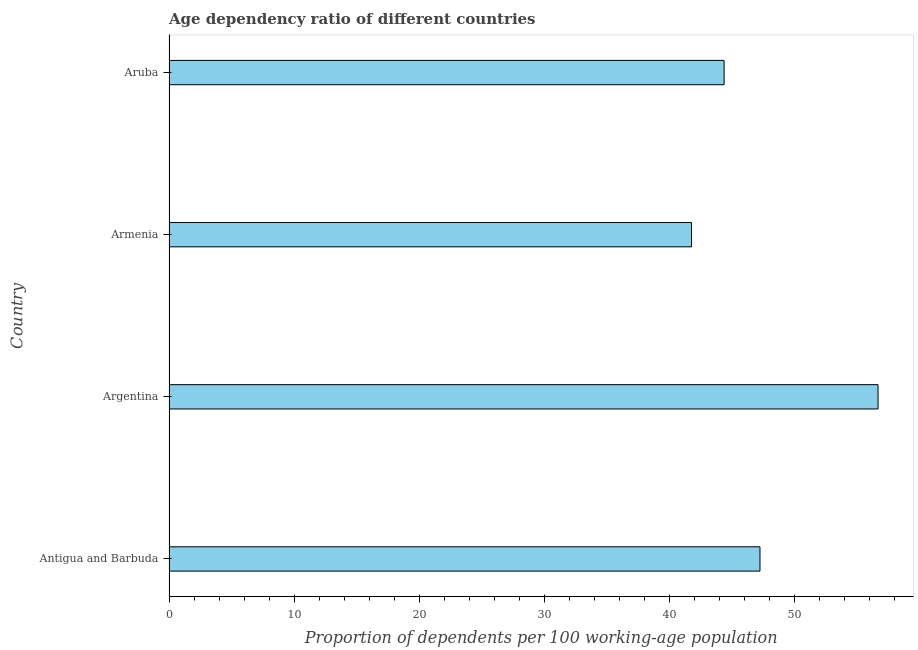Does the graph contain grids?
Your response must be concise. No. What is the title of the graph?
Give a very brief answer. Age dependency ratio of different countries. What is the label or title of the X-axis?
Provide a succinct answer. Proportion of dependents per 100 working-age population. What is the age dependency ratio in Argentina?
Your response must be concise. 56.66. Across all countries, what is the maximum age dependency ratio?
Your answer should be compact. 56.66. Across all countries, what is the minimum age dependency ratio?
Provide a short and direct response. 41.75. In which country was the age dependency ratio minimum?
Provide a short and direct response. Armenia. What is the sum of the age dependency ratio?
Your response must be concise. 189.98. What is the difference between the age dependency ratio in Armenia and Aruba?
Offer a terse response. -2.6. What is the average age dependency ratio per country?
Your answer should be compact. 47.5. What is the median age dependency ratio?
Keep it short and to the point. 45.79. What is the ratio of the age dependency ratio in Argentina to that in Armenia?
Ensure brevity in your answer.  1.36. Is the difference between the age dependency ratio in Antigua and Barbuda and Aruba greater than the difference between any two countries?
Keep it short and to the point. No. What is the difference between the highest and the second highest age dependency ratio?
Give a very brief answer. 9.43. Is the sum of the age dependency ratio in Argentina and Armenia greater than the maximum age dependency ratio across all countries?
Your answer should be compact. Yes. How many bars are there?
Your answer should be very brief. 4. Are all the bars in the graph horizontal?
Give a very brief answer. Yes. How many countries are there in the graph?
Provide a succinct answer. 4. Are the values on the major ticks of X-axis written in scientific E-notation?
Your answer should be very brief. No. What is the Proportion of dependents per 100 working-age population of Antigua and Barbuda?
Make the answer very short. 47.22. What is the Proportion of dependents per 100 working-age population of Argentina?
Ensure brevity in your answer.  56.66. What is the Proportion of dependents per 100 working-age population of Armenia?
Offer a terse response. 41.75. What is the Proportion of dependents per 100 working-age population of Aruba?
Your response must be concise. 44.36. What is the difference between the Proportion of dependents per 100 working-age population in Antigua and Barbuda and Argentina?
Your response must be concise. -9.43. What is the difference between the Proportion of dependents per 100 working-age population in Antigua and Barbuda and Armenia?
Provide a short and direct response. 5.47. What is the difference between the Proportion of dependents per 100 working-age population in Antigua and Barbuda and Aruba?
Your answer should be very brief. 2.87. What is the difference between the Proportion of dependents per 100 working-age population in Argentina and Armenia?
Your response must be concise. 14.9. What is the difference between the Proportion of dependents per 100 working-age population in Argentina and Aruba?
Make the answer very short. 12.3. What is the difference between the Proportion of dependents per 100 working-age population in Armenia and Aruba?
Offer a very short reply. -2.6. What is the ratio of the Proportion of dependents per 100 working-age population in Antigua and Barbuda to that in Argentina?
Ensure brevity in your answer.  0.83. What is the ratio of the Proportion of dependents per 100 working-age population in Antigua and Barbuda to that in Armenia?
Your answer should be very brief. 1.13. What is the ratio of the Proportion of dependents per 100 working-age population in Antigua and Barbuda to that in Aruba?
Keep it short and to the point. 1.06. What is the ratio of the Proportion of dependents per 100 working-age population in Argentina to that in Armenia?
Offer a terse response. 1.36. What is the ratio of the Proportion of dependents per 100 working-age population in Argentina to that in Aruba?
Your answer should be compact. 1.28. What is the ratio of the Proportion of dependents per 100 working-age population in Armenia to that in Aruba?
Provide a succinct answer. 0.94. 